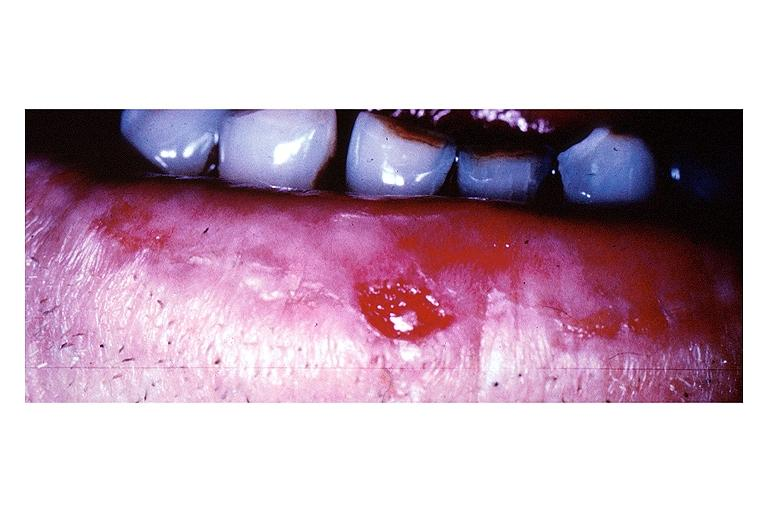does myocardium show squamous cell carcinoma?
Answer the question using a single word or phrase. No 